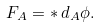Convert formula to latex. <formula><loc_0><loc_0><loc_500><loc_500>F _ { A } = * \, d _ { A } \phi .</formula> 